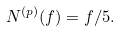Convert formula to latex. <formula><loc_0><loc_0><loc_500><loc_500>N ^ { ( p ) } ( f ) = f / 5 .</formula> 